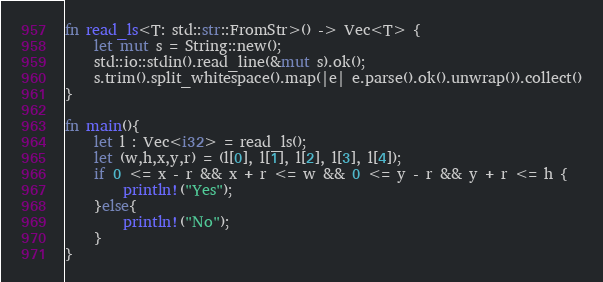<code> <loc_0><loc_0><loc_500><loc_500><_Rust_>fn read_ls<T: std::str::FromStr>() -> Vec<T> {
    let mut s = String::new();
    std::io::stdin().read_line(&mut s).ok();
    s.trim().split_whitespace().map(|e| e.parse().ok().unwrap()).collect()
}

fn main(){
    let l : Vec<i32> = read_ls();
    let (w,h,x,y,r) = (l[0], l[1], l[2], l[3], l[4]);
    if 0 <= x - r && x + r <= w && 0 <= y - r && y + r <= h {  
        println!("Yes");
    }else{
        println!("No");
    }
}


</code> 